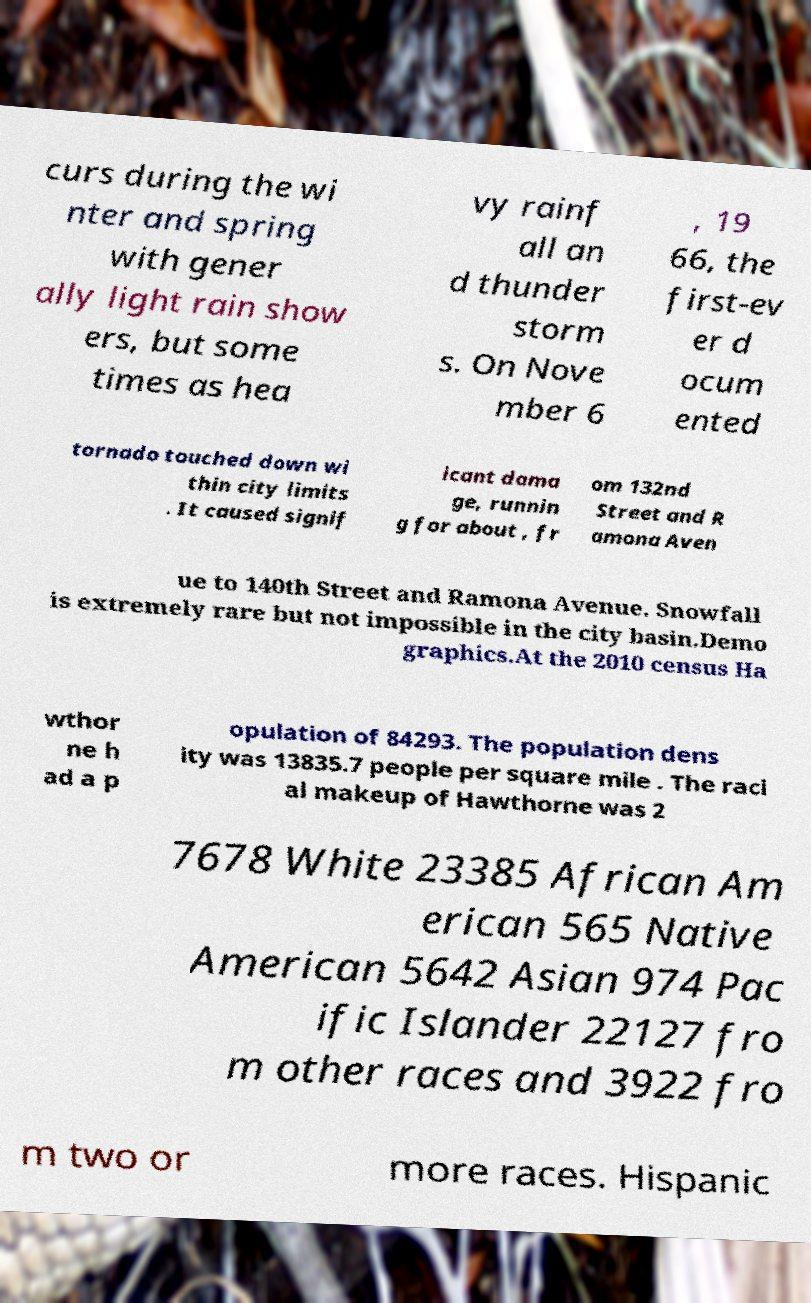What messages or text are displayed in this image? I need them in a readable, typed format. curs during the wi nter and spring with gener ally light rain show ers, but some times as hea vy rainf all an d thunder storm s. On Nove mber 6 , 19 66, the first-ev er d ocum ented tornado touched down wi thin city limits . It caused signif icant dama ge, runnin g for about , fr om 132nd Street and R amona Aven ue to 140th Street and Ramona Avenue. Snowfall is extremely rare but not impossible in the city basin.Demo graphics.At the 2010 census Ha wthor ne h ad a p opulation of 84293. The population dens ity was 13835.7 people per square mile . The raci al makeup of Hawthorne was 2 7678 White 23385 African Am erican 565 Native American 5642 Asian 974 Pac ific Islander 22127 fro m other races and 3922 fro m two or more races. Hispanic 